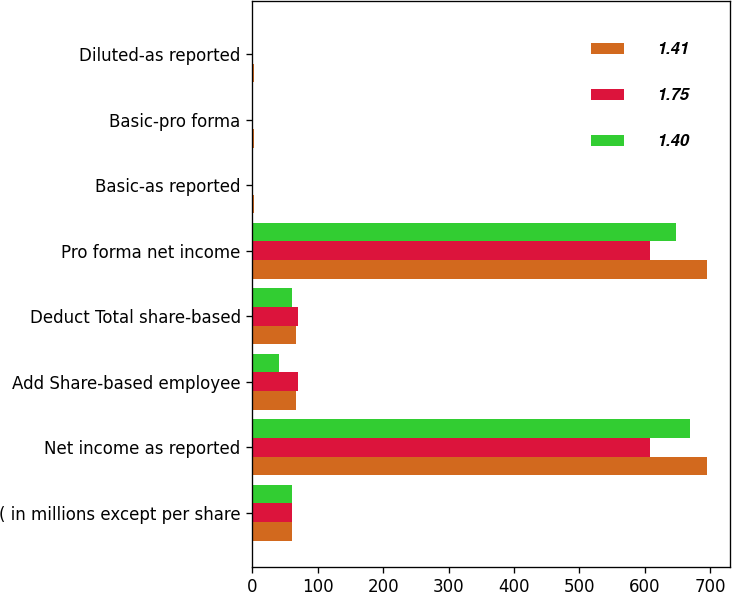Convert chart to OTSL. <chart><loc_0><loc_0><loc_500><loc_500><stacked_bar_chart><ecel><fcel>( in millions except per share<fcel>Net income as reported<fcel>Add Share-based employee<fcel>Deduct Total share-based<fcel>Pro forma net income<fcel>Basic-as reported<fcel>Basic-pro forma<fcel>Diluted-as reported<nl><fcel>1.41<fcel>61<fcel>696<fcel>67<fcel>67<fcel>696<fcel>1.85<fcel>1.85<fcel>1.75<nl><fcel>1.75<fcel>61<fcel>608<fcel>70<fcel>70<fcel>608<fcel>1.5<fcel>1.5<fcel>1.41<nl><fcel>1.4<fcel>61<fcel>669<fcel>40<fcel>61<fcel>648<fcel>1.55<fcel>1.5<fcel>1.45<nl></chart> 